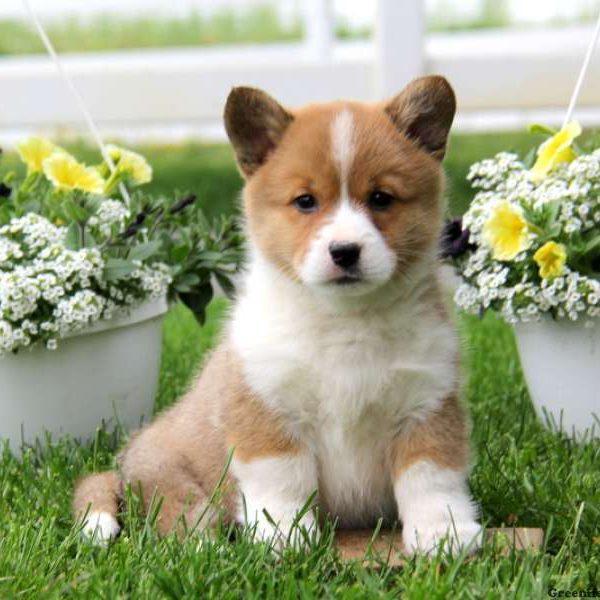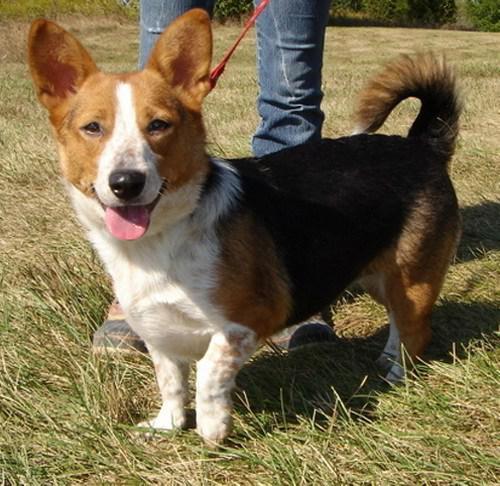The first image is the image on the left, the second image is the image on the right. Given the left and right images, does the statement "An image shows one dog with upright ears posed with white flowers." hold true? Answer yes or no. Yes. The first image is the image on the left, the second image is the image on the right. For the images displayed, is the sentence "The dog in the image on the right is standing on all fours in the grass." factually correct? Answer yes or no. Yes. 